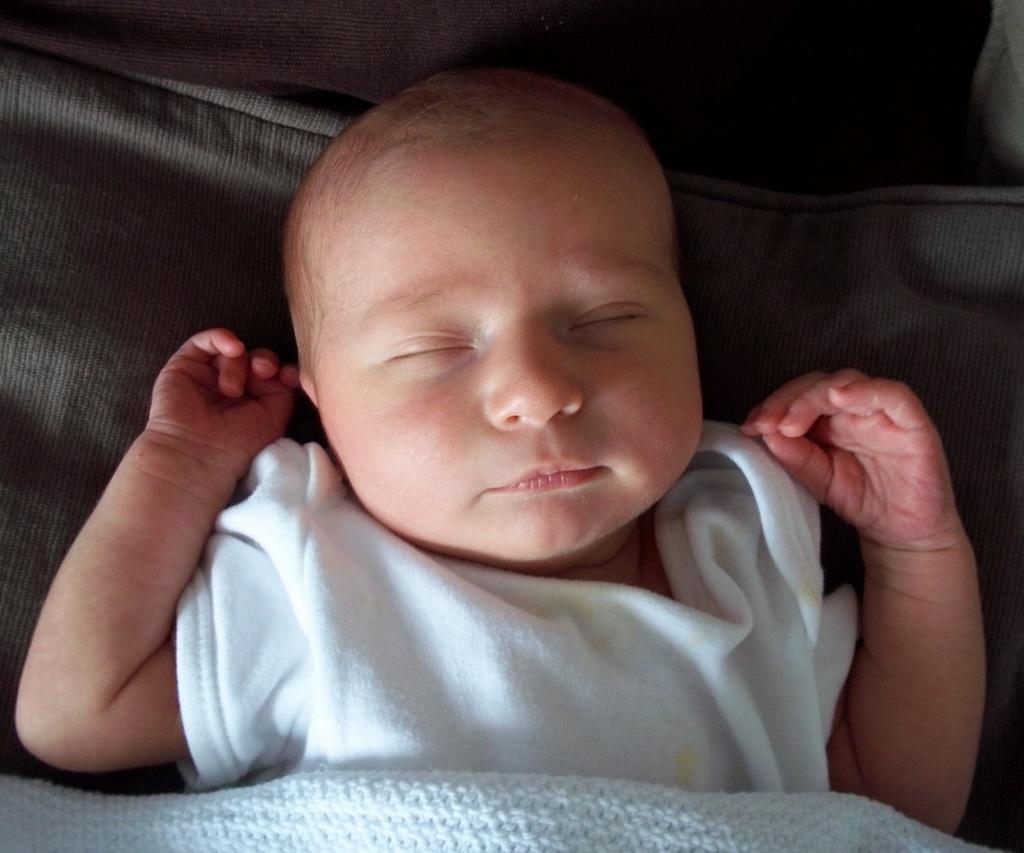Describe this image in one or two sentences. in this picture there is a baby with white color dress is lying on the bed and there is a white color blanket on the baby. 